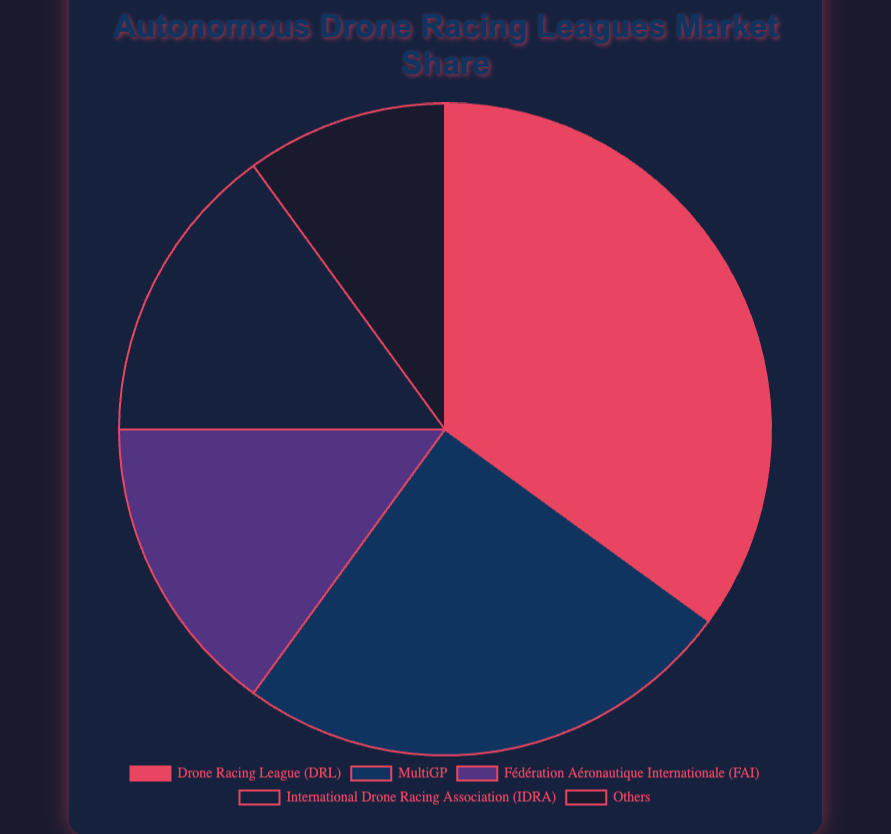Which league has the highest market share? From the pie chart, it is clear that the league with the largest portion is the Drone Racing League (DRL), which holds 35% of the market share.
Answer: Drone Racing League (DRL) Which two leagues have equal market shares? The sectors representing both the Fédération Aéronautique Internationale (FAI) and the International Drone Racing Association (IDRA) have the same size in the pie chart, each accounting for 15% of the market share.
Answer: Fédération Aéronautique Internationale (FAI) and International Drone Racing Association (IDRA) What is the total market share of leagues other than DRL? To find the total market share of leagues other than DRL, sum the percentage shares of MultiGP, FAI, IDRA, and Others: 25% + 15% + 15% + 10% = 65%.
Answer: 65% How much larger is the market share of DRL compared to Others? The market share of DRL is 35%, and the market share of Others is 10%. The difference is 35% - 10% = 25%.
Answer: 25% What is the combined market share of the two smallest leagues? The two smallest leagues are FAI and Others, each with market shares of 15% and 10%, respectively. Summing them up gives 15% + 10% = 25%.
Answer: 25% Rank the leagues in descending order of their market shares. We arrange the leagues by their market shares as follows: Drone Racing League (DRL) 35%, MultiGP 25%, Fédération Aéronautique Internationale (FAI) 15%, International Drone Racing Association (IDRA) 15%, and Others 10%.
Answer: Drone Racing League (DRL), MultiGP, Fédération Aéronautique Internationale (FAI), International Drone Racing Association (IDRA), Others Which occupied color represents the International Drone Racing Association (IDRA) in the chart? Based on color and sector, the IDRA league's section corresponds to the dark blue color of the pie chart.
Answer: dark blue What is the average market share of MultiGP, FAI, and IDRA? To calculate the average market share of these three leagues, sum their shares: 25% + 15% + 15% = 55%, then divide by the number of leagues, which is 3. So, the average is 55% / 3 ≈ 18.33%.
Answer: 18.33% 